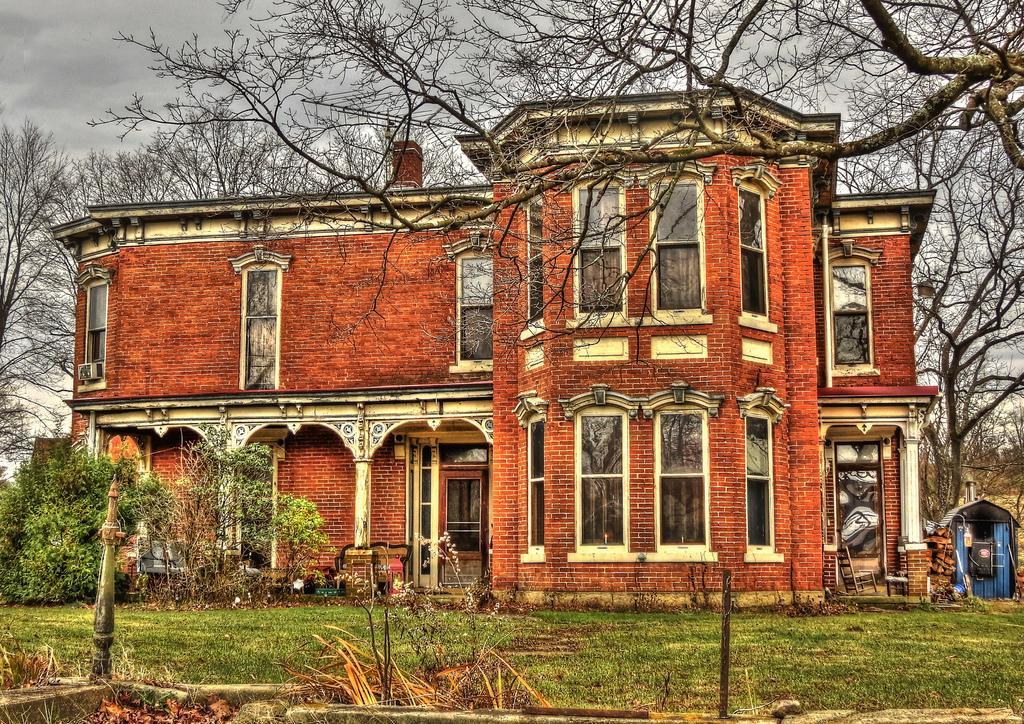Could you give a brief overview of what you see in this image? In this image I can see the building with windows and the shed. In-front of the building I can see the poles and the plants. In the background I can see many trees, clouds and the sky. 